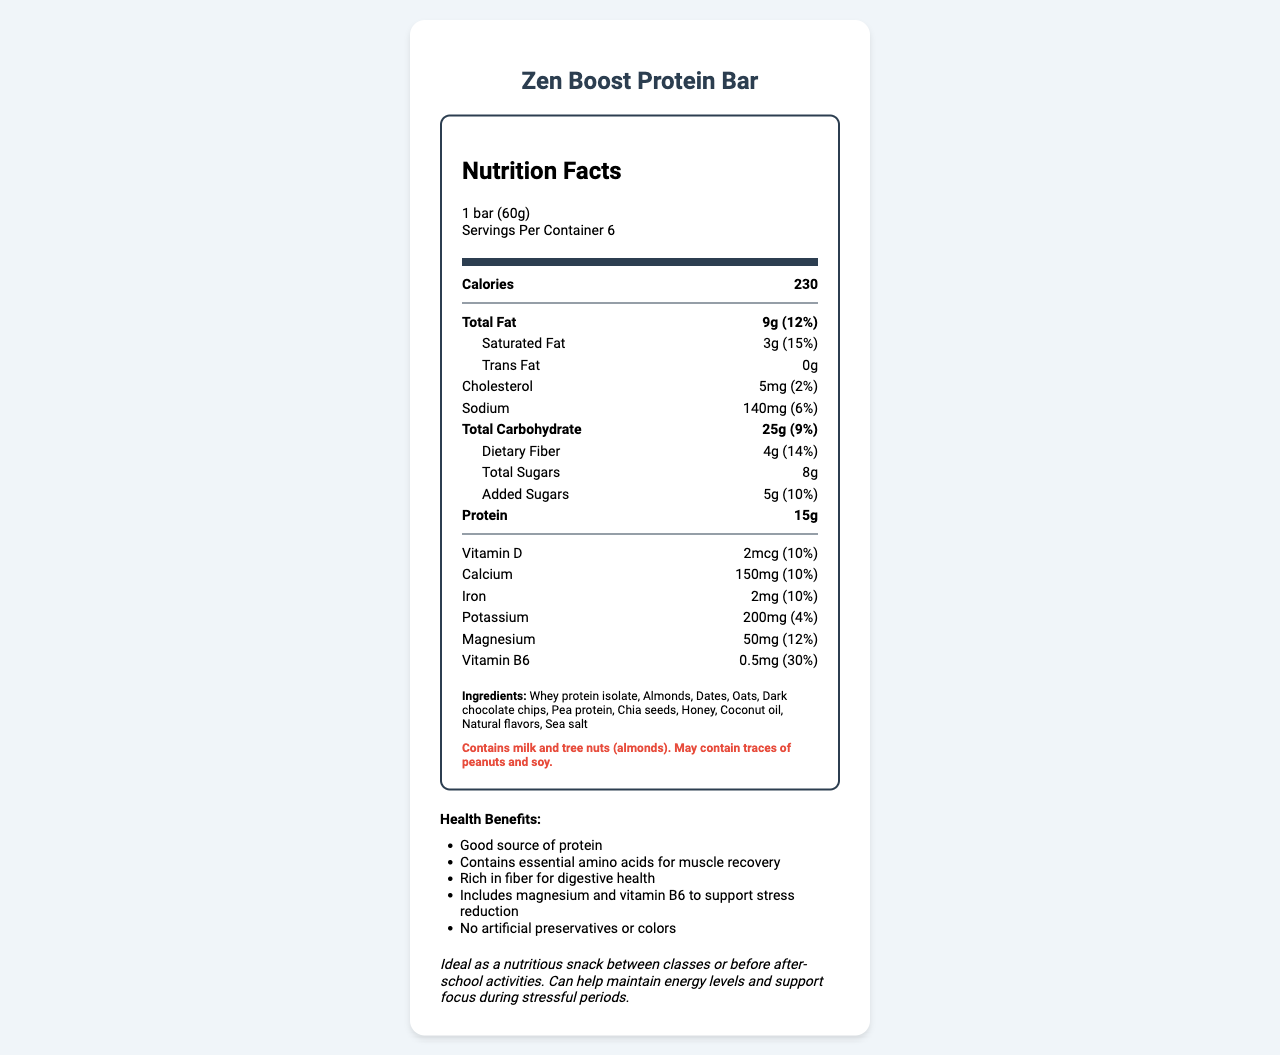what is the serving size for Zen Boost Protein Bar? The document states that the serving size is 1 bar (60g).
Answer: 1 bar (60g) how many calories are in one serving? The document lists the calorie count for one serving as 230 calories.
Answer: 230 which ingredient is listed first in the ingredients section? The document's ingredient section lists "Whey protein isolate" as the first ingredient.
Answer: Whey protein isolate how much dietary fiber does one serving contain? The document states that one serving contains 4g of dietary fiber.
Answer: 4g what allergies should consumers be aware of? The allergen information indicates that the product contains milk and tree nuts (almonds).
Answer: Milk and tree nuts (almonds) which nutrient has the highest daily value percentage? A. Vitamin D B. Magnesium C. Vitamin B6 D. Calcium Vitamin B6 has the highest daily value percentage at 30%.
Answer: C. Vitamin B6 how much protein does one serving contain? A. 10g B. 12g C. 15g D. 20g The document specifies that one serving contains 15g of protein.
Answer: C. 15g does Zen Boost Protein Bar contain any trans fat? The document lists trans fat as 0g.
Answer: No what is the recommended use for Zen Boost Protein Bar? The document provides a recommended use section indicating this information.
Answer: Ideal as a nutritious snack between classes or before after-school activities. Can help maintain energy levels and support focus during stressful periods. does the product contain any artificial preservatives or colors? One of the health claims is that the product includes no artificial preservatives or colors.
Answer: No what are some health benefits mentioned in the document? The health claims section lists these benefits.
Answer: Good source of protein, Contains essential amino acids for muscle recovery, Rich in fiber for digestive health, Includes magnesium and vitamin B6 to support stress reduction, No artificial preservatives or colors summarize the main idea of the document The document combines various pieces of specific information to present a comprehensive overview of the product's nutritional profile and benefits.
Answer: The document provides a detailed Nutrition Facts Label for the Zen Boost Protein Bar, highlighting its nutritional content, ingredients, allergen information, health benefits, recommended use, and storage instructions. It positions the bar as a nutritious snack suitable for high school students to help maintain energy and support focus during stressful periods. who is the manufacturer of Zen Boost Protein Bar? The document lists the manufacturer as NutriWell Foods, Inc.
Answer: NutriWell Foods, Inc. how should the product be stored? The storage instructions indicate to store in a cool, dry place and consume within 7 days of opening.
Answer: Store in a cool, dry place. Consume within 7 days of opening. what is the distribution address for the product? The distribution section mentions "Distributed by Health First Nutrition, Los Angeles, CA 90001", but the exact distribution address cannot be determined from the information provided.
Answer: Cannot be determined 